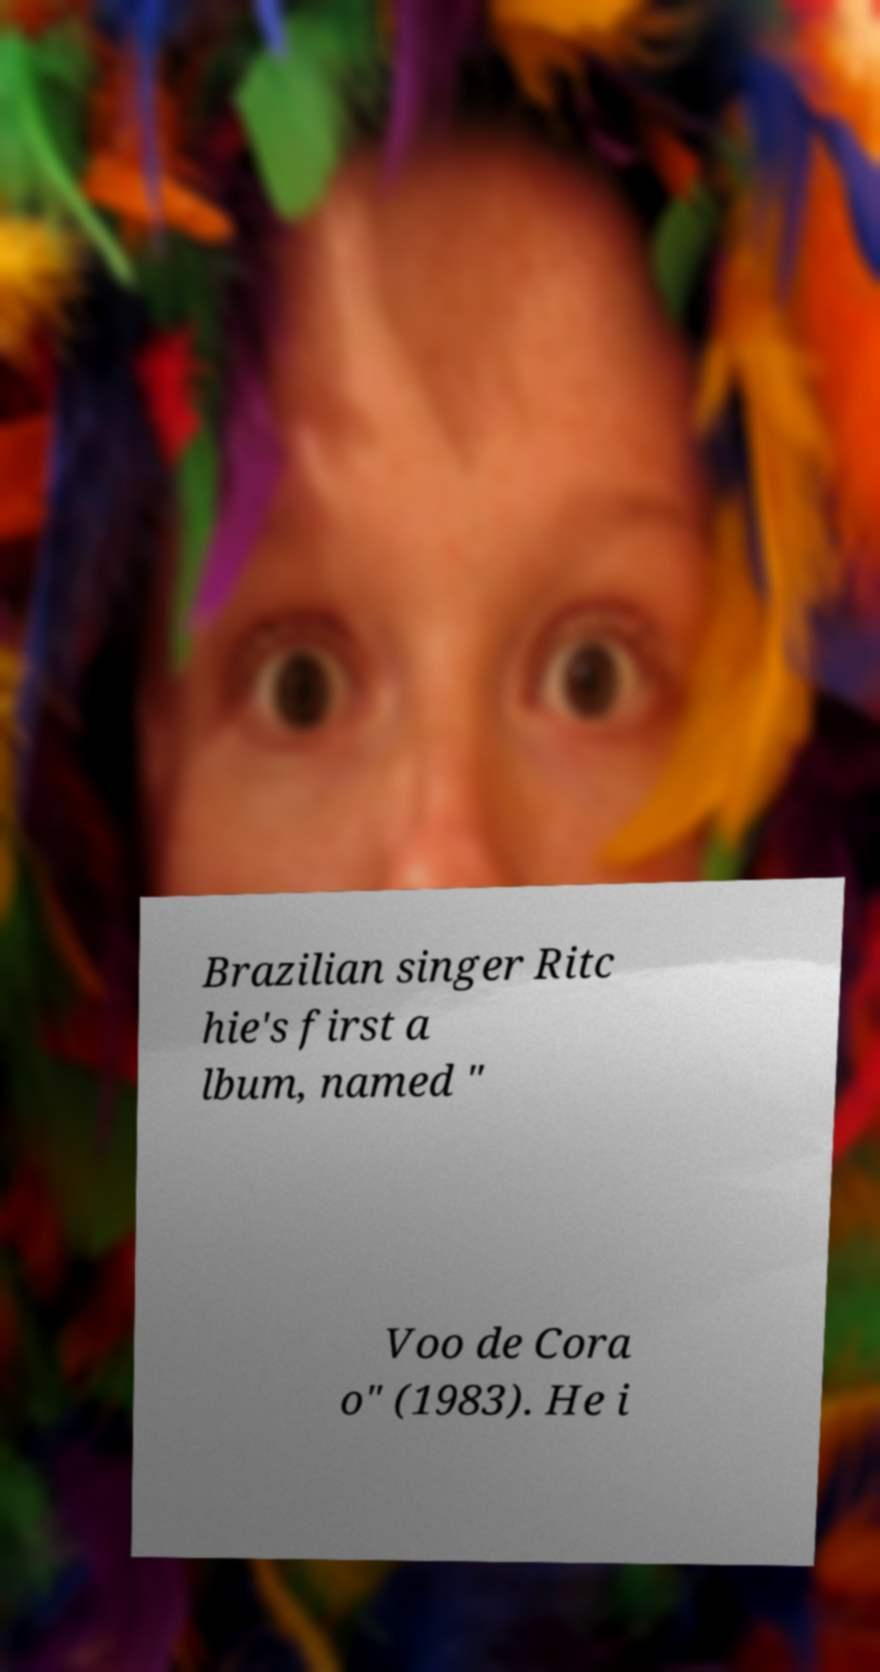For documentation purposes, I need the text within this image transcribed. Could you provide that? Brazilian singer Ritc hie's first a lbum, named " Voo de Cora o" (1983). He i 